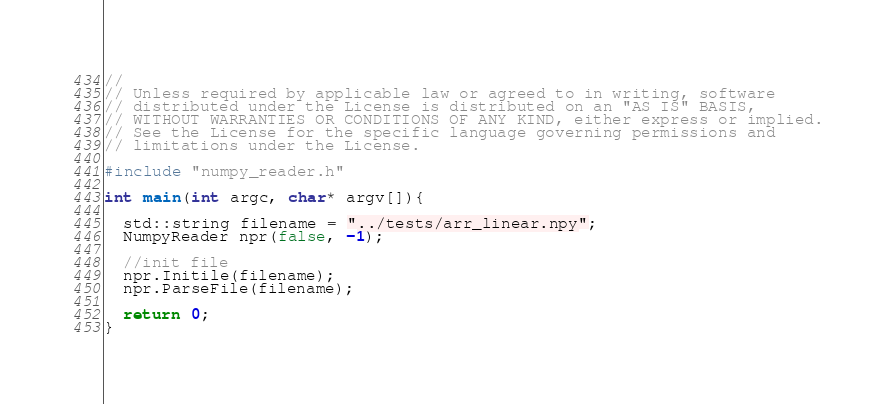Convert code to text. <code><loc_0><loc_0><loc_500><loc_500><_C++_>//
// Unless required by applicable law or agreed to in writing, software
// distributed under the License is distributed on an "AS IS" BASIS,
// WITHOUT WARRANTIES OR CONDITIONS OF ANY KIND, either express or implied.
// See the License for the specific language governing permissions and
// limitations under the License.

#include "numpy_reader.h"

int main(int argc, char* argv[]){

  std::string filename = "../tests/arr_linear.npy";
  NumpyReader npr(false, -1);

  //init file
  npr.Initile(filename);
  npr.ParseFile(filename);
  
  return 0;
}
</code> 